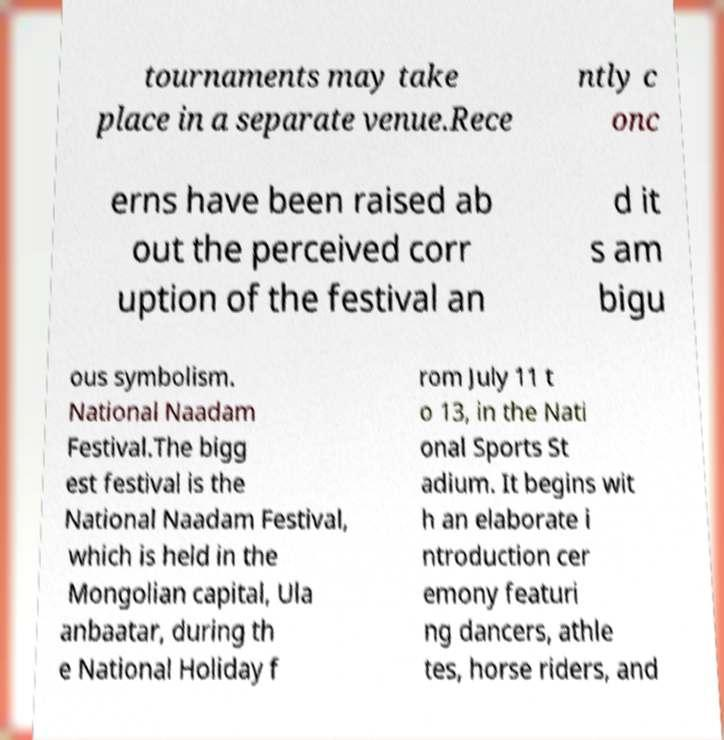For documentation purposes, I need the text within this image transcribed. Could you provide that? tournaments may take place in a separate venue.Rece ntly c onc erns have been raised ab out the perceived corr uption of the festival an d it s am bigu ous symbolism. National Naadam Festival.The bigg est festival is the National Naadam Festival, which is held in the Mongolian capital, Ula anbaatar, during th e National Holiday f rom July 11 t o 13, in the Nati onal Sports St adium. It begins wit h an elaborate i ntroduction cer emony featuri ng dancers, athle tes, horse riders, and 